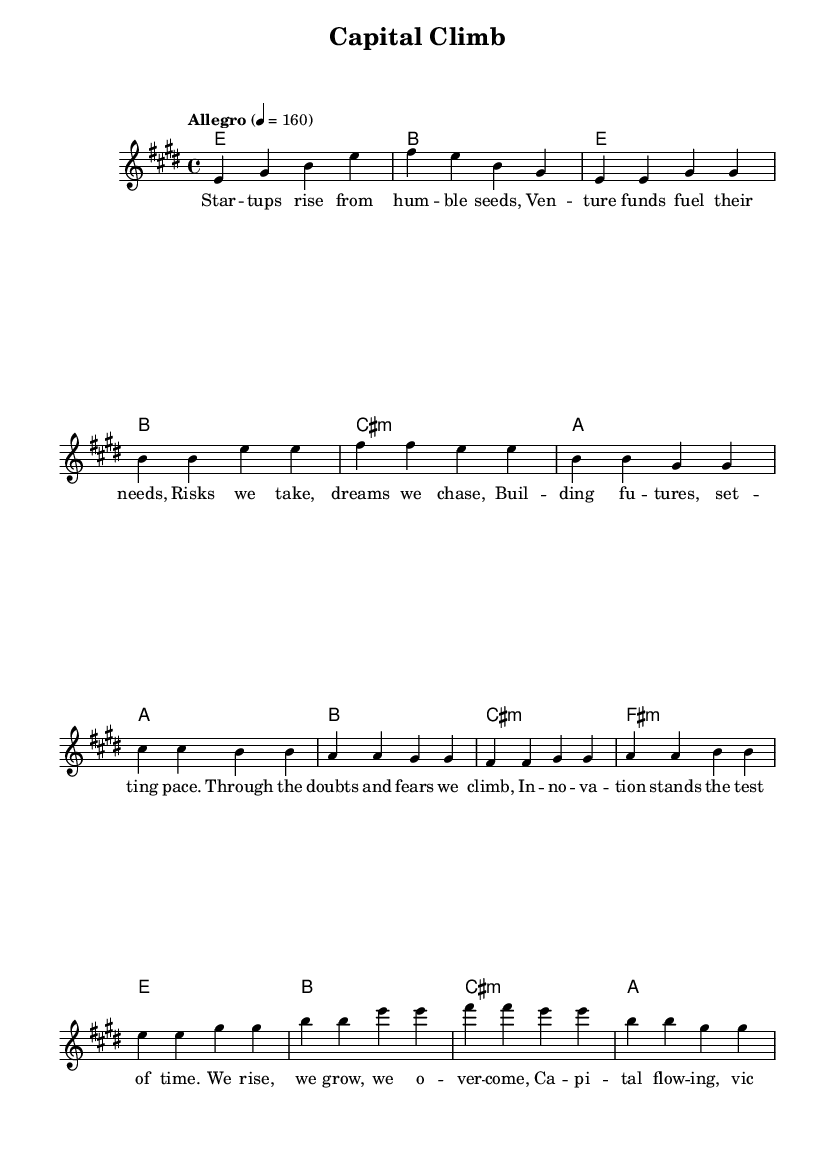What is the key signature of this music? The key signature is E major, which contains four sharps (F#, C#, G#, and D#). This is indicated at the beginning of the sheet music.
Answer: E major What is the time signature of this music? The time signature is 4/4, which means there are four beats per measure, and each quarter note gets one beat. This is shown at the beginning of the piece.
Answer: 4/4 What is the tempo marking for this piece? The tempo marking is "Allegro" with a metronome marking of 160 beats per minute, indicating a lively and fast pace. This is stated above the music staff in the score.
Answer: Allegro 4 = 160 How many measures does the verse contain? The verse contains eight measures, as indicated by counting the numbered measures in the verse section of the sheet music.
Answer: Eight measures What is the emotional theme represented in the lyrics of this piece? The emotional theme of the lyrics centers around overcoming adversity and achieving growth through innovation and effort. The lyrics reflect optimism and a determination to succeed.
Answer: Overcoming adversity In which section does the lyrics highlight the idea of innovation standing the test of time? The idea of innovation standing the test of time is highlighted in the pre-chorus section of the lyrics, which emphasizes resilience and the pursuit of dreams amidst challenges.
Answer: Pre-Chorus What chords accompany the chorus section? The chords that accompany the chorus section are E major, B major, C sharp minor, and A major. These chords create a powerful progression that supports the energetic feel of the anthem.
Answer: E, B, C sharp minor, A 